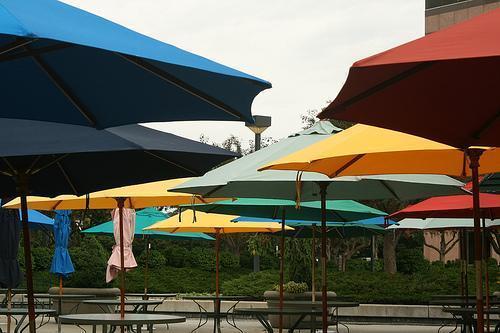How many yellow umbrellas are in this photo?
Give a very brief answer. 3. 